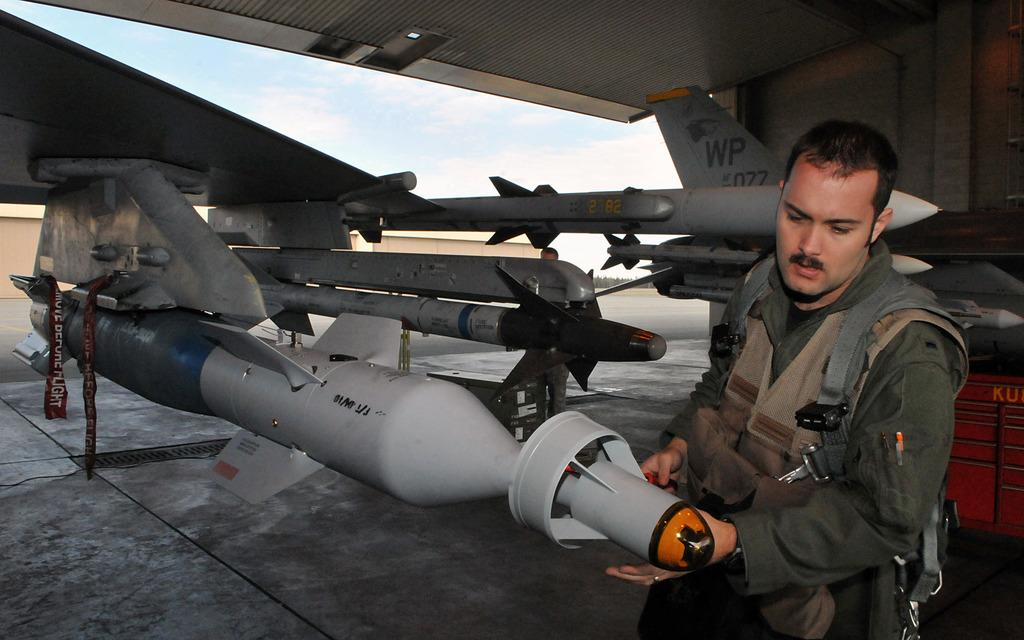<image>
Present a compact description of the photo's key features. A man inspects a rocket; the word flight can be seen in the background. 